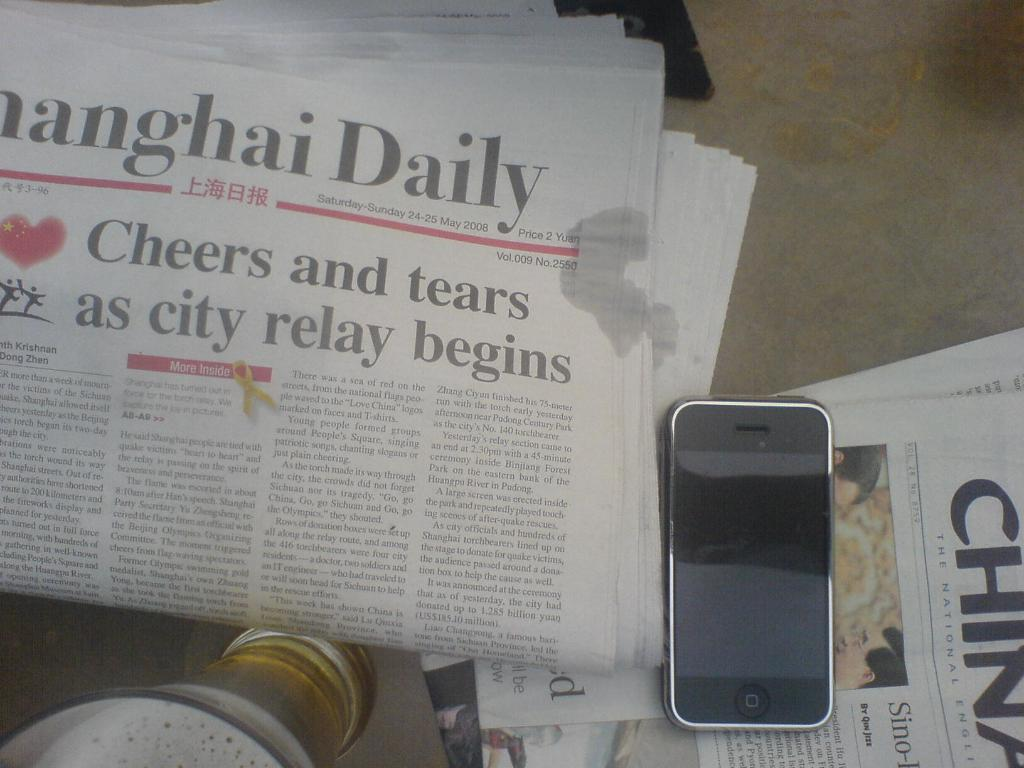Where was the image taken? The image is taken indoors. What furniture is present in the image? There is a table in the image. What items are on the table? There are newspapers, a mobile phone, and a glass with wine on the table. What type of operation is being performed on the bat in the image? There is no bat present in the image, and therefore no operation is being performed on it. 